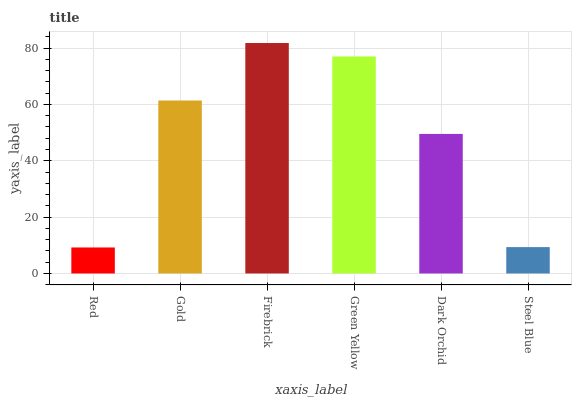Is Red the minimum?
Answer yes or no. Yes. Is Firebrick the maximum?
Answer yes or no. Yes. Is Gold the minimum?
Answer yes or no. No. Is Gold the maximum?
Answer yes or no. No. Is Gold greater than Red?
Answer yes or no. Yes. Is Red less than Gold?
Answer yes or no. Yes. Is Red greater than Gold?
Answer yes or no. No. Is Gold less than Red?
Answer yes or no. No. Is Gold the high median?
Answer yes or no. Yes. Is Dark Orchid the low median?
Answer yes or no. Yes. Is Green Yellow the high median?
Answer yes or no. No. Is Green Yellow the low median?
Answer yes or no. No. 